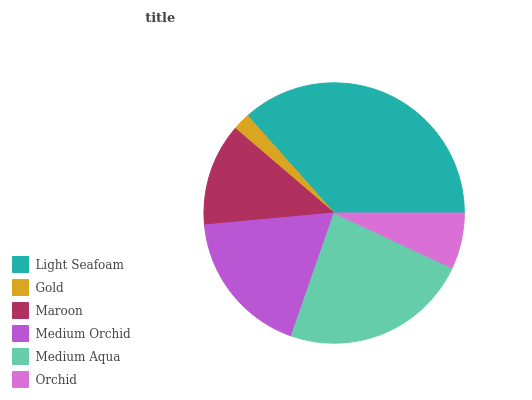Is Gold the minimum?
Answer yes or no. Yes. Is Light Seafoam the maximum?
Answer yes or no. Yes. Is Maroon the minimum?
Answer yes or no. No. Is Maroon the maximum?
Answer yes or no. No. Is Maroon greater than Gold?
Answer yes or no. Yes. Is Gold less than Maroon?
Answer yes or no. Yes. Is Gold greater than Maroon?
Answer yes or no. No. Is Maroon less than Gold?
Answer yes or no. No. Is Medium Orchid the high median?
Answer yes or no. Yes. Is Maroon the low median?
Answer yes or no. Yes. Is Gold the high median?
Answer yes or no. No. Is Orchid the low median?
Answer yes or no. No. 